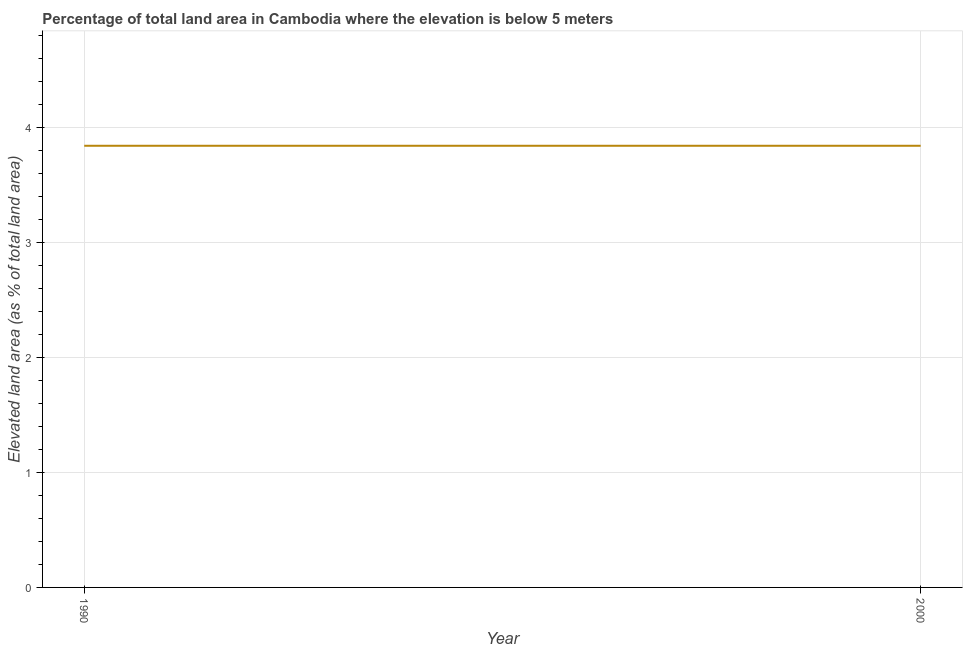What is the total elevated land area in 2000?
Provide a short and direct response. 3.84. Across all years, what is the maximum total elevated land area?
Make the answer very short. 3.84. Across all years, what is the minimum total elevated land area?
Provide a short and direct response. 3.84. In which year was the total elevated land area minimum?
Your answer should be compact. 1990. What is the sum of the total elevated land area?
Provide a short and direct response. 7.68. What is the difference between the total elevated land area in 1990 and 2000?
Offer a very short reply. 0. What is the average total elevated land area per year?
Your response must be concise. 3.84. What is the median total elevated land area?
Ensure brevity in your answer.  3.84. In how many years, is the total elevated land area greater than 0.6000000000000001 %?
Give a very brief answer. 2. Do a majority of the years between 1990 and 2000 (inclusive) have total elevated land area greater than 3.4 %?
Provide a succinct answer. Yes. Is the total elevated land area in 1990 less than that in 2000?
Your answer should be compact. No. Does the total elevated land area monotonically increase over the years?
Your answer should be compact. No. Are the values on the major ticks of Y-axis written in scientific E-notation?
Offer a very short reply. No. Does the graph contain any zero values?
Provide a succinct answer. No. What is the title of the graph?
Your answer should be compact. Percentage of total land area in Cambodia where the elevation is below 5 meters. What is the label or title of the X-axis?
Ensure brevity in your answer.  Year. What is the label or title of the Y-axis?
Your response must be concise. Elevated land area (as % of total land area). What is the Elevated land area (as % of total land area) of 1990?
Keep it short and to the point. 3.84. What is the Elevated land area (as % of total land area) in 2000?
Give a very brief answer. 3.84. 